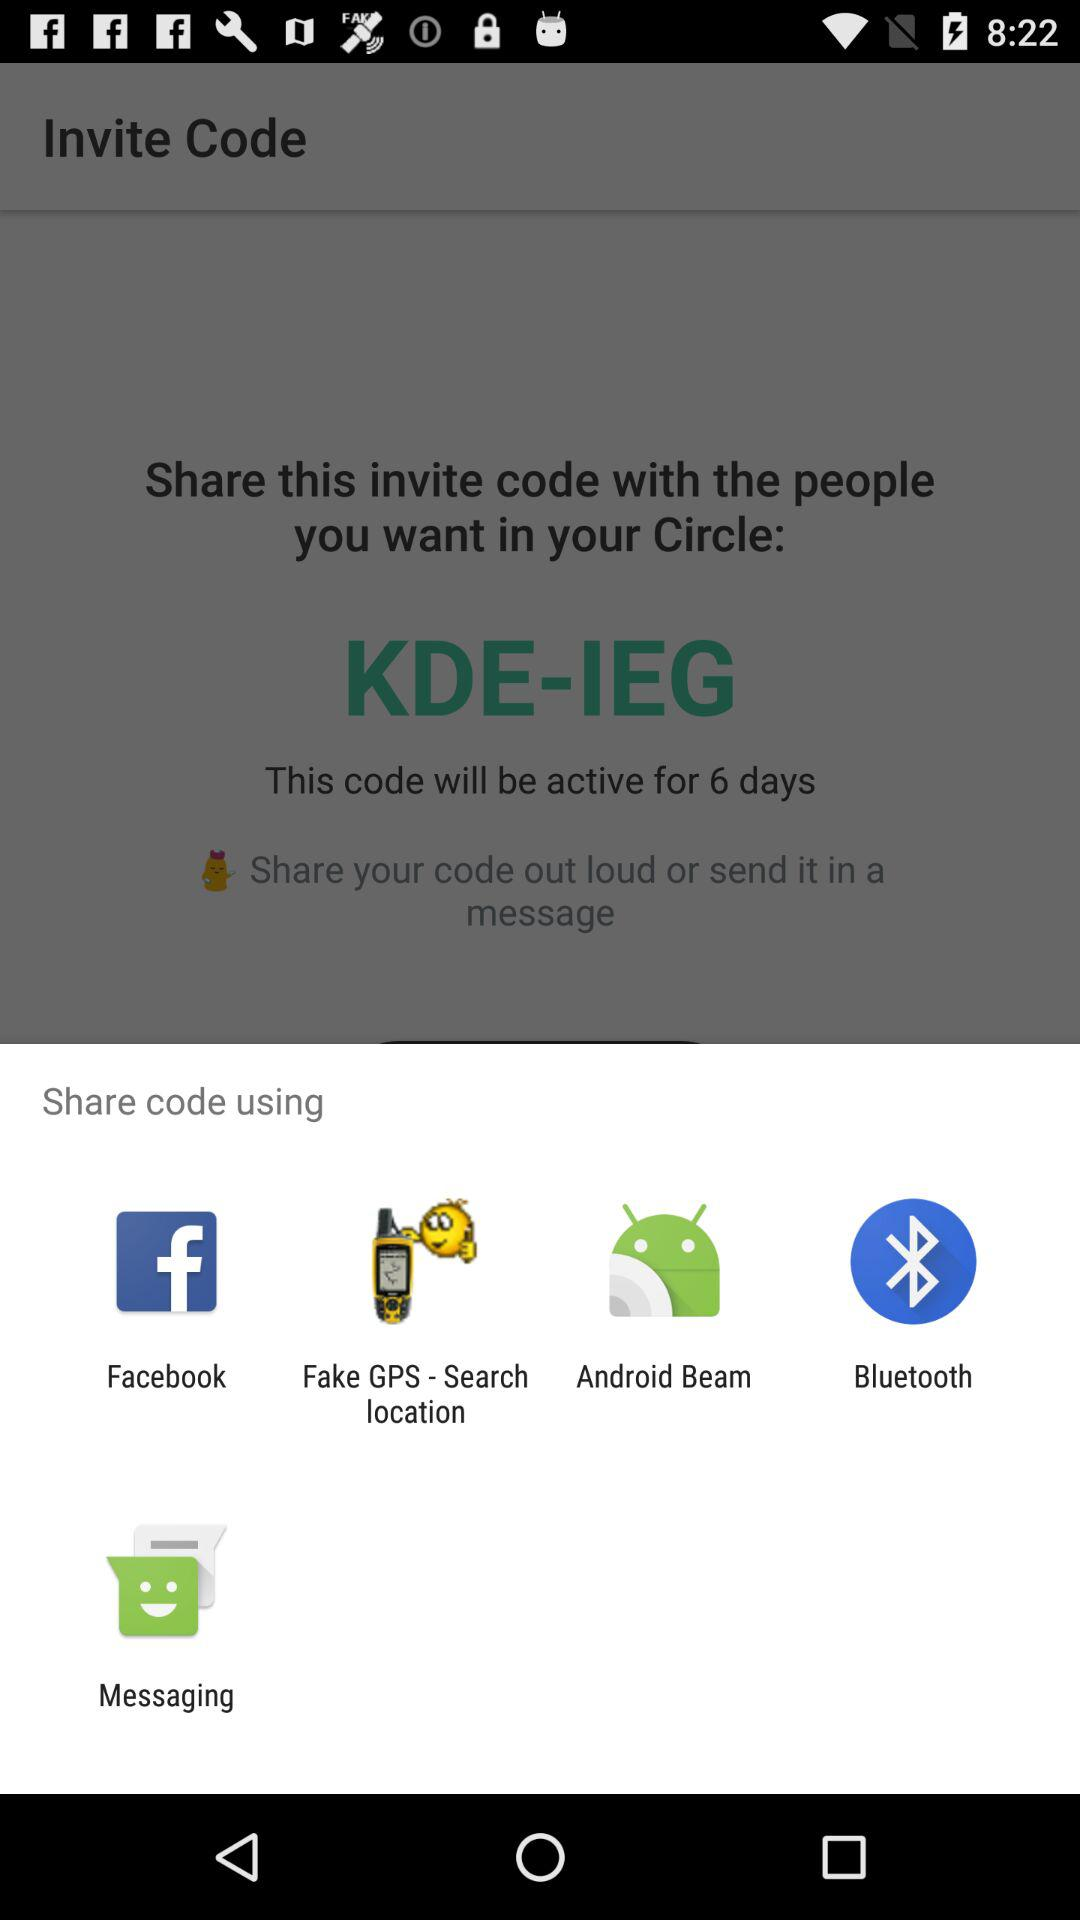What are the different applications through which we can share the code? You can share the code through "Facebook", "Fake GPS - Search location", "Android Beam", "Bluetooth" and "Messaging". 